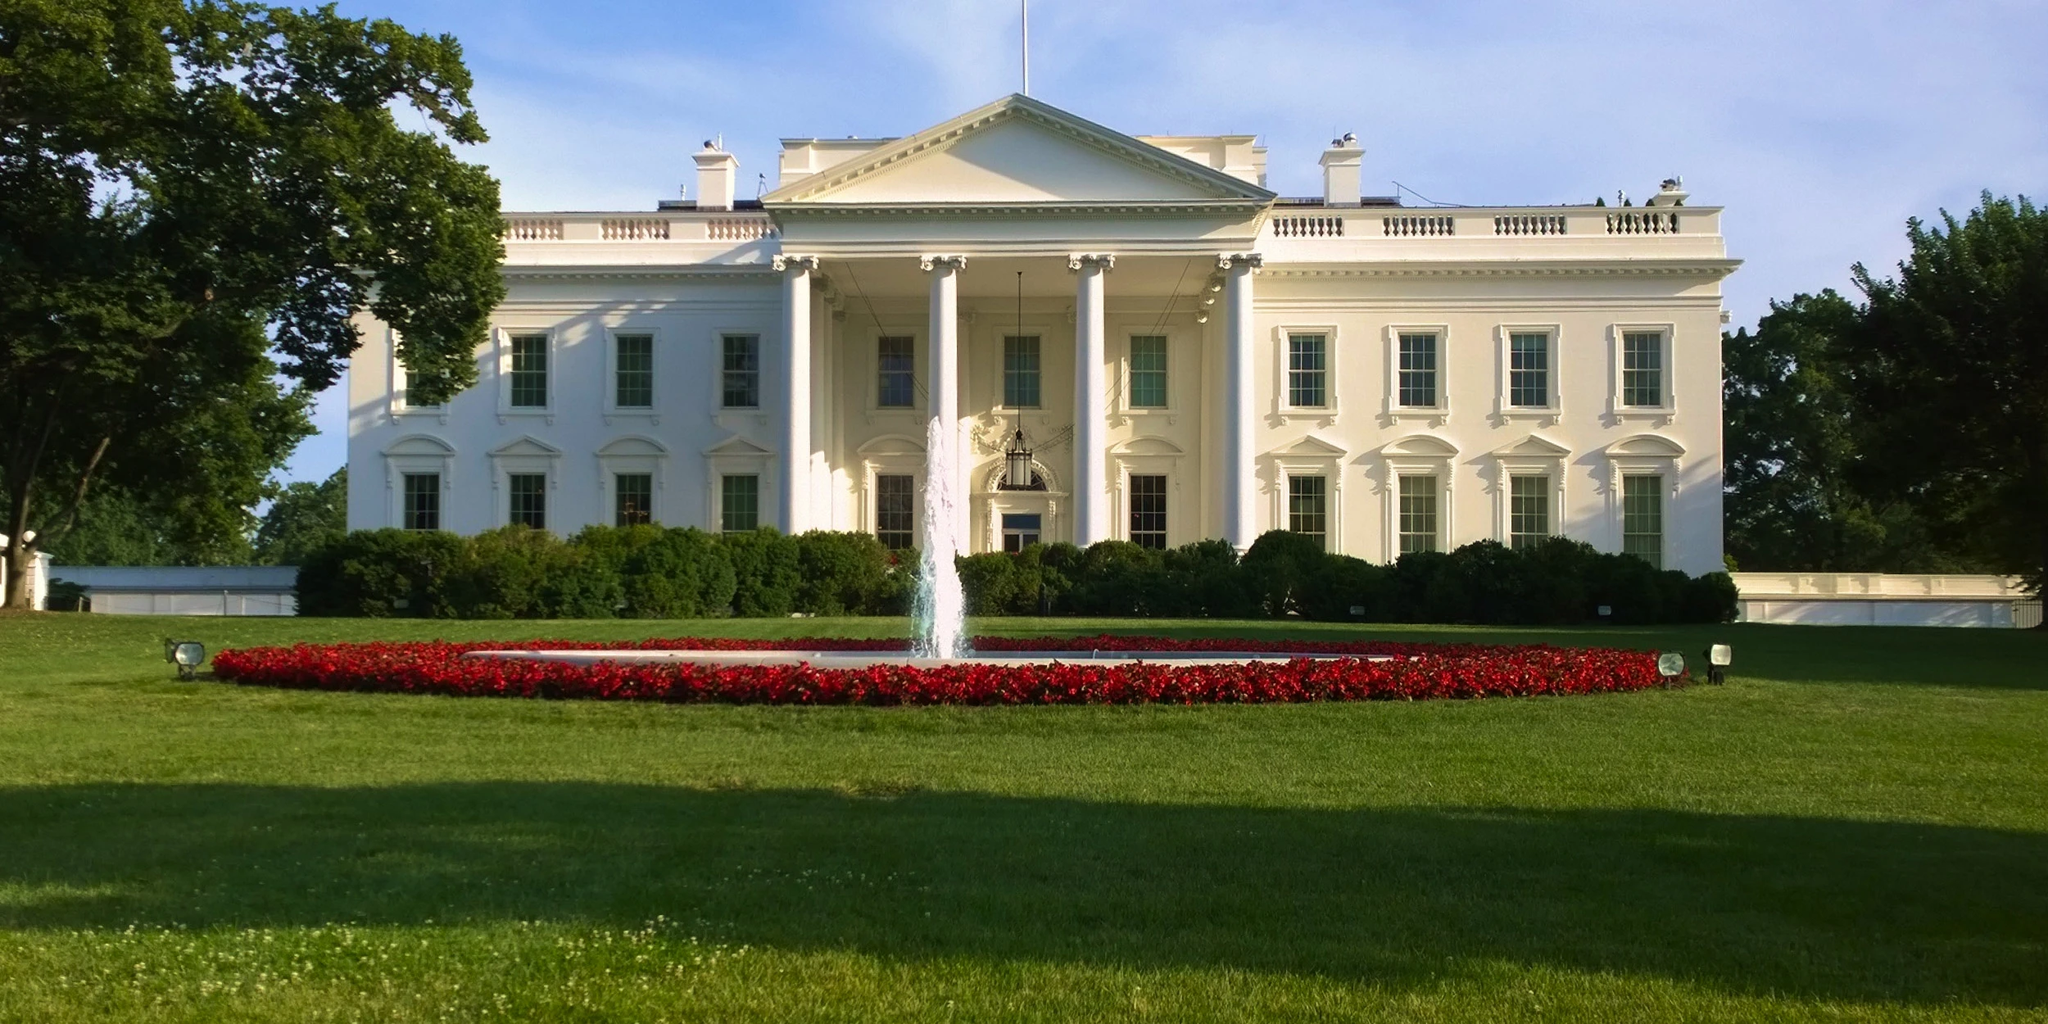What if the White House had a secret underground garden filled with exotic plants and rare species? Imagine if the White House had a secret underground garden, a hidden marvel filled with exotic plants and rare species from around the world. This garden, accessible only to a select few, would be a sanctuary of biodiversity, showcasing flora from remote corners of the globe. It could feature bioluminescent plants that glow in the dark, towering trees with blossoms that change color, and rare medicinal herbs with historical significance. Such a garden would not only be a horticultural masterpiece but also a symbol of nature's wonder, a place where science and beauty converge in an extraordinary subterranean oasis. 